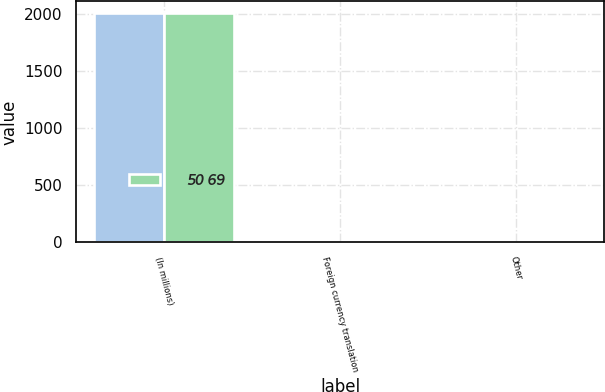Convert chart. <chart><loc_0><loc_0><loc_500><loc_500><stacked_bar_chart><ecel><fcel>(In millions)<fcel>Foreign currency translation<fcel>Other<nl><fcel>nan<fcel>2010<fcel>3<fcel>2<nl><fcel>50 69<fcel>2009<fcel>2<fcel>4<nl></chart> 